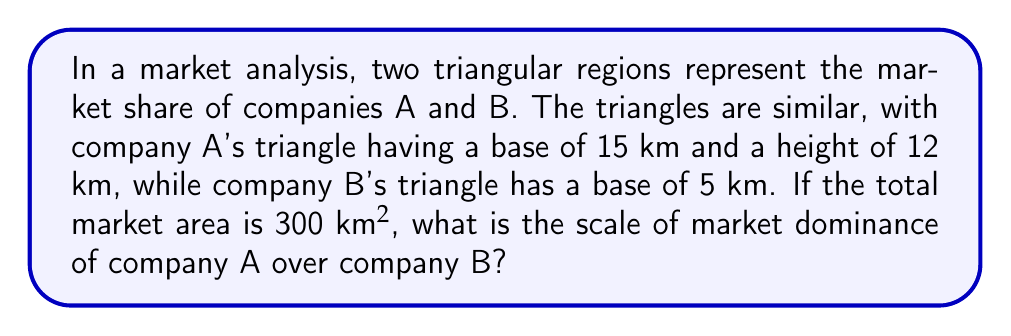Give your solution to this math problem. Let's approach this step-by-step:

1) First, we need to find the height of company B's triangle. Since the triangles are similar, we can use the scale factor:

   $$\frac{\text{Base A}}{\text{Base B}} = \frac{15}{5} = 3$$

   This means that all dimensions of triangle A are 3 times those of triangle B.

2) So, if the height of A is 12 km, the height of B is:

   $$\text{Height B} = \frac{12}{3} = 4 \text{ km}$$

3) Now we can calculate the areas of both triangles:

   Area of A: $$A_A = \frac{1}{2} \times 15 \times 12 = 90 \text{ km}^2$$
   Area of B: $$A_B = \frac{1}{2} \times 5 \times 4 = 10 \text{ km}^2$$

4) The scale of market dominance can be represented as the ratio of these areas:

   $$\text{Scale of dominance} = \frac{A_A}{A_B} = \frac{90}{10} = 9$$

5) We can verify this by noting that the scale factor for linear dimensions (3) squared gives us the scale factor for areas (9).

6) This means company A's market share is 9 times larger than company B's.

7) To express this as a ratio, we can say the market dominance is 9:1.
Answer: 9:1 